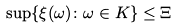Convert formula to latex. <formula><loc_0><loc_0><loc_500><loc_500>\sup \{ \xi ( \omega ) \colon \omega \in K \} \leq \Xi</formula> 